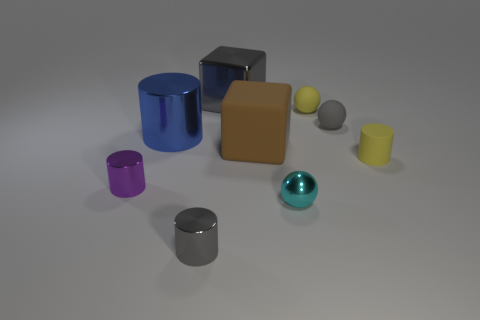Can you describe the textures visible on the objects? The objects in the image display a variety of smooth textures with matte and slightly reflective surfaces, indicating a lack of significant texture details like bumps or roughness. Do any of the objects seem to have a different material from the others? The turquoise sphere in the foreground stands out with a shinier, more reflective surface, suggesting it may be made of a different material, possibly a polished metal or glazed ceramic, as opposed to the others which look like colored plastic. 